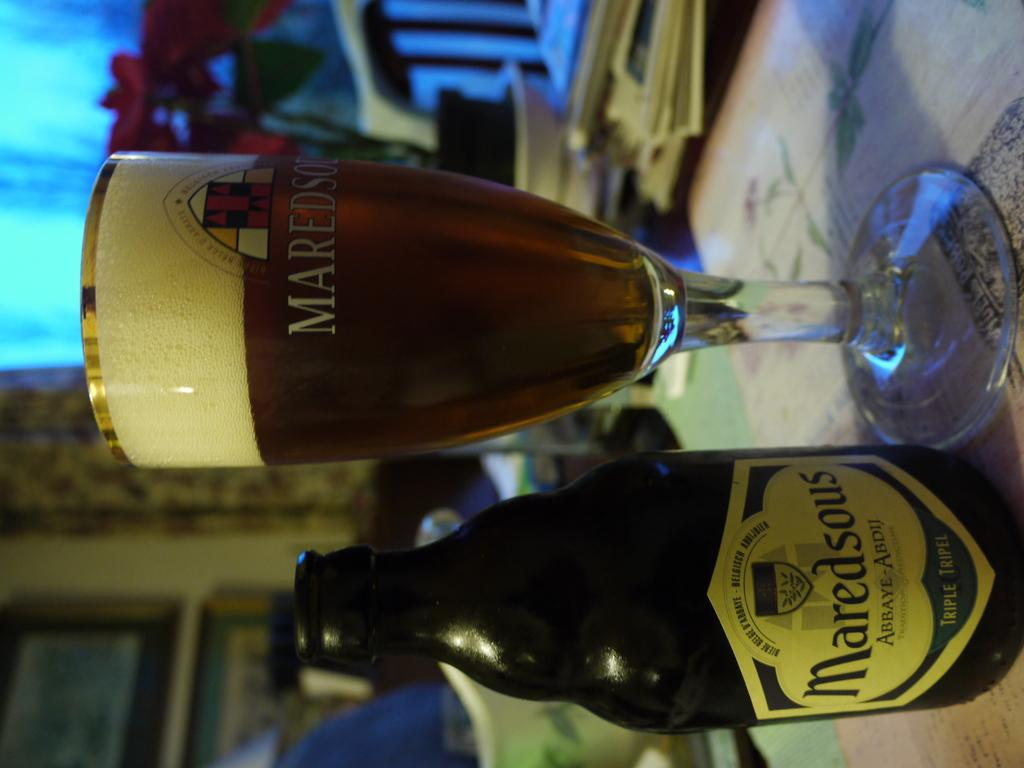<image>
Give a short and clear explanation of the subsequent image. Maredsous is imprinted on a bottle sitting beside the glass. 